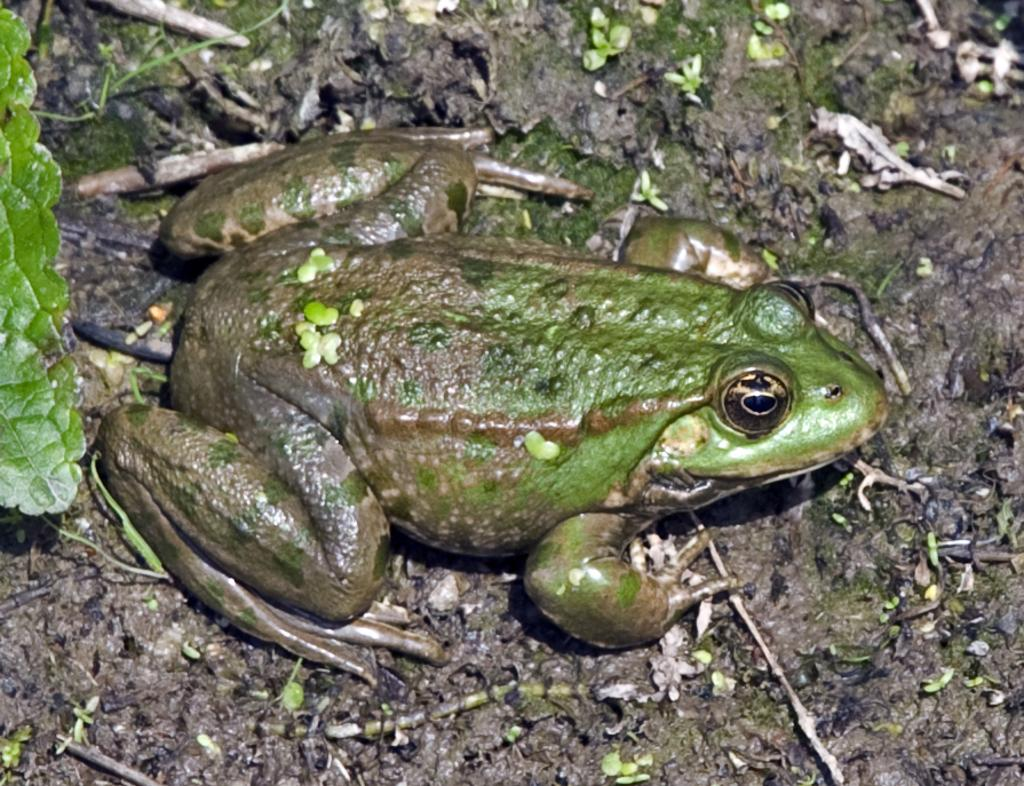What animal is present in the image? There is a frog in the image. Where is the frog located? The frog is on the mud. What other object can be seen in the image? There is a leaf in the image. What type of humor can be seen in the image? There is no humor present in the image; it features a frog on mud and a leaf. How many arms does the frog have in the image? Frogs do not have arms; they have front limbs called forelimbs and hind limbs called hind limbs. In the image, the frog has four limbs, two forelimbs and two hind limbs. 